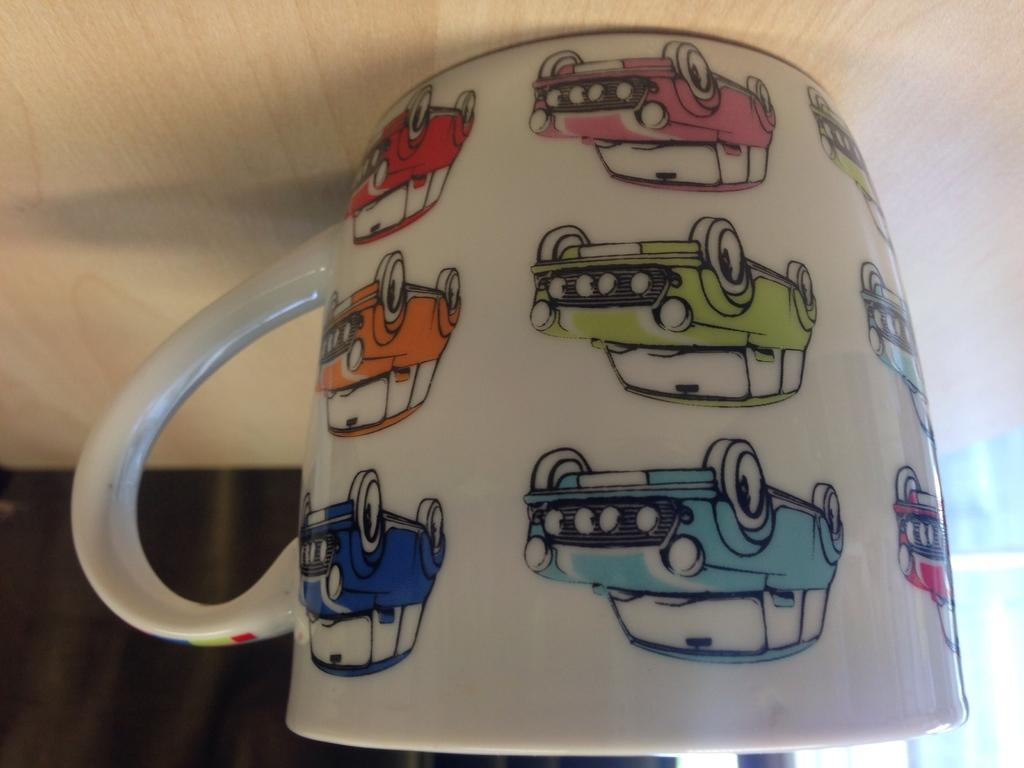What is present on the wooden surface in the image? There is a cup on the wooden surface in the image. What is depicted on the cup? The cup has car images on it. What type of memory does the pig have in the image? There is no pig present in the image, so it is not possible to determine what type of memory it might have. 